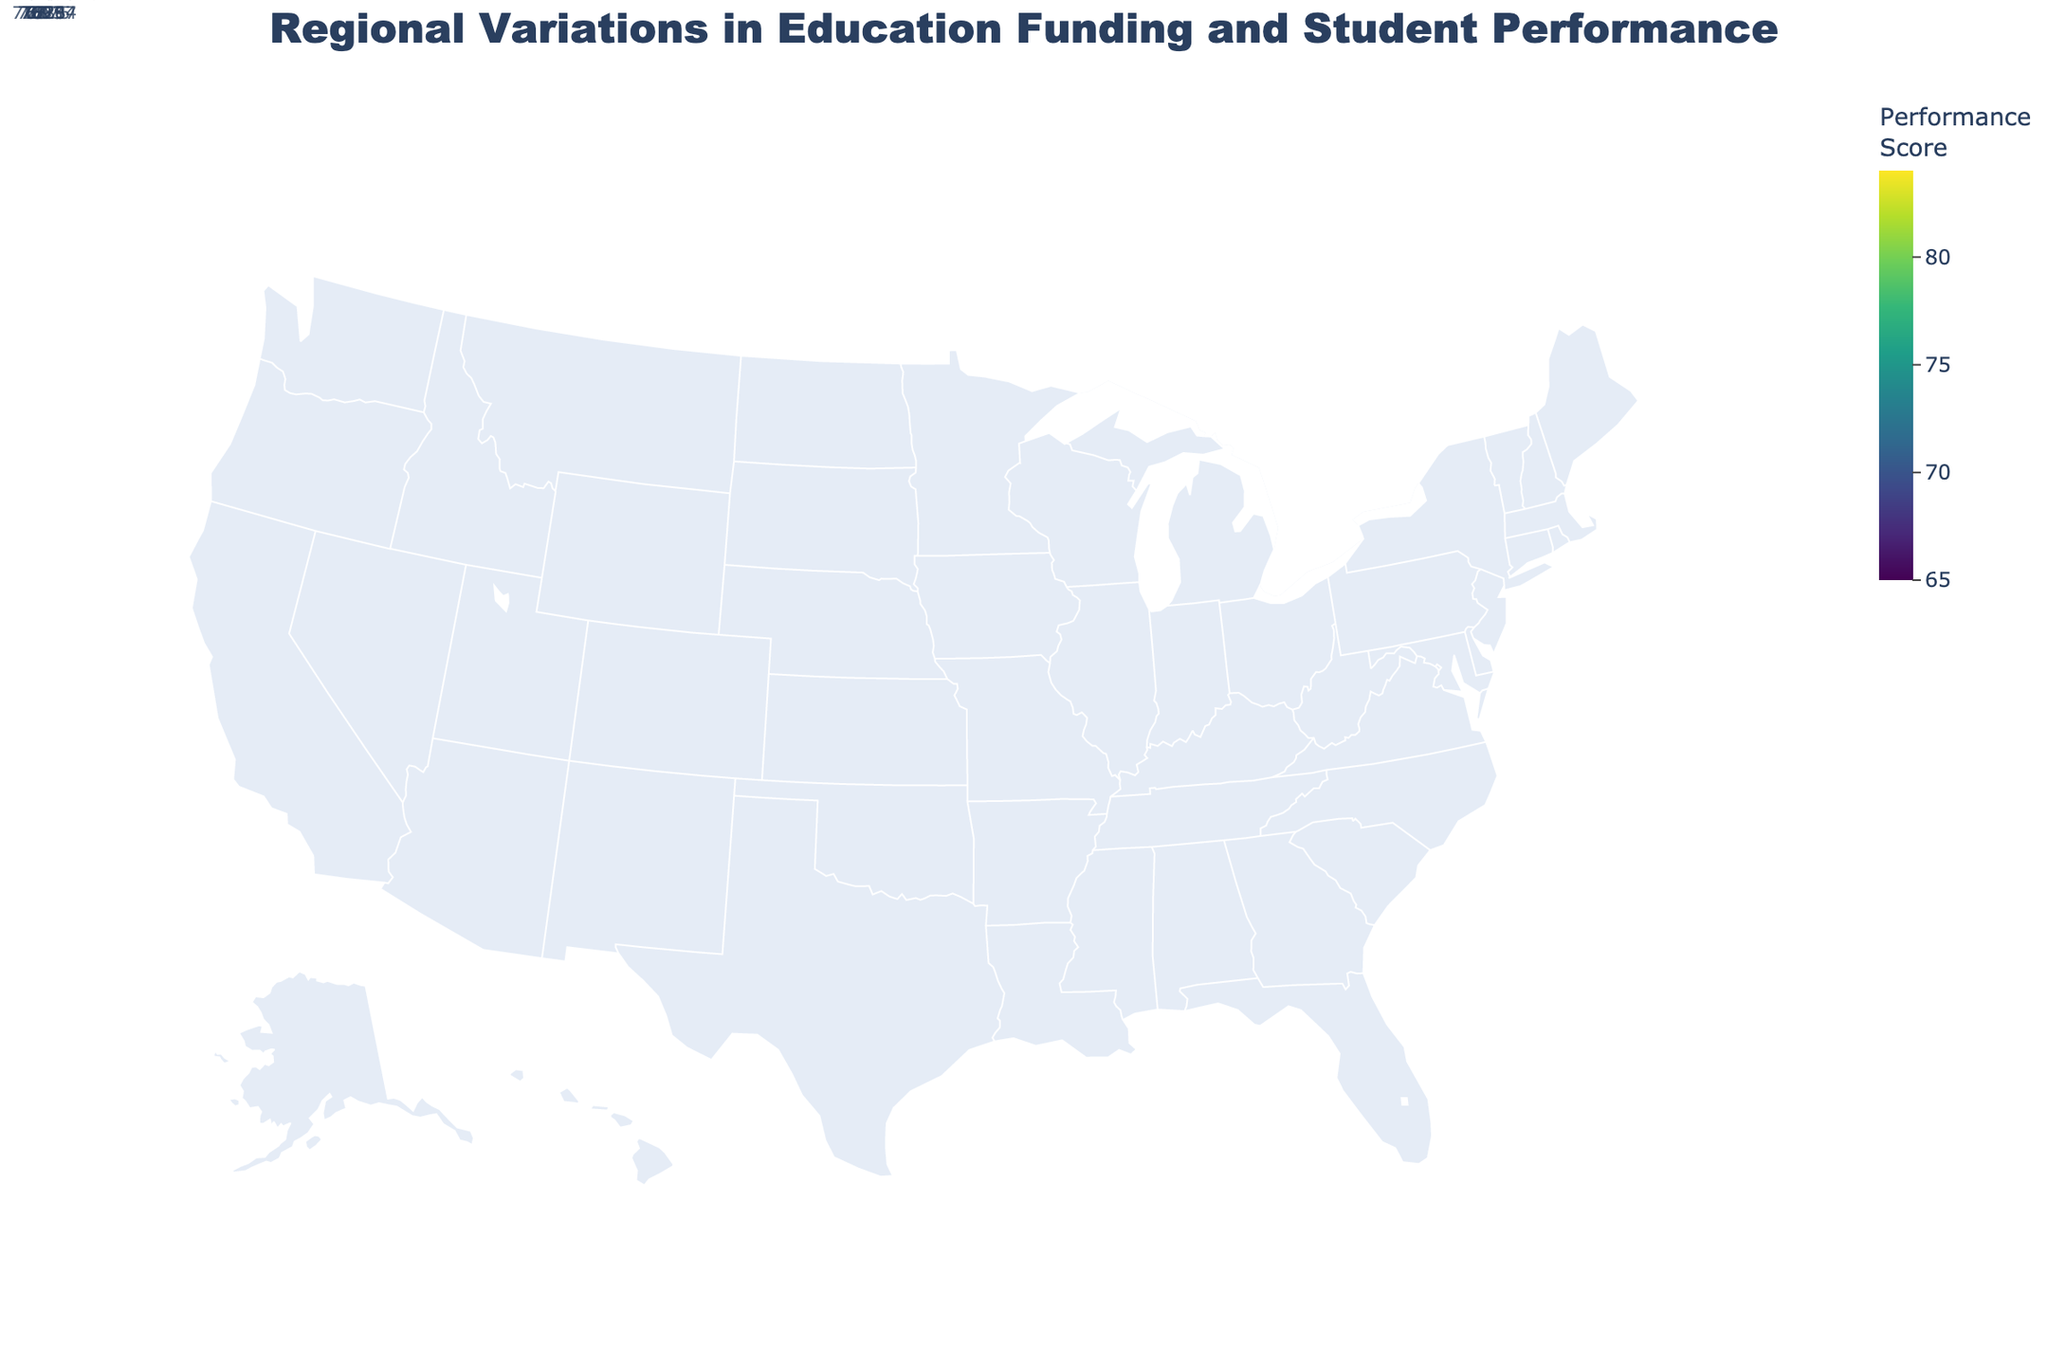What is the title of the figure? The title is given at the top of the figure. It summarizes the information presented.
Answer: Regional Variations in Education Funding and Student Performance Which state has the highest student performance score? Look at the states colored with the darkest shade on the color scale, which indicates higher performance scores, and identify the state with the score of 84.
Answer: Massachusetts How much is the education funding per student in Texas? Check the hover data for Texas, which shows detailed information including education funding per student.
Answer: $9800 What's the difference in student performance scores between California and Michigan? Note the performance scores for both California (78) and Michigan (69) and subtract the lower score from the higher score.
Answer: 9 Which region recommends the largest budget reallocation? Identify the state with the highest value for the 'Recommended Budget Reallocation'. The state with the largest reallocation percentage is 35%.
Answer: Arizona What is the average student performance score across all states? Add up all the student performance scores and divide by the number of states (15 states). Calculation: (78 + 72 + 82 + 70 + 76 + 75 + 71 + 69 + 68 + 67 + 77 + 79 + 84 + 83 + 65) / 15.
Answer: 74.1 How does Florida's student performance score compare to the national average? Determine Florida’s performance score, then calculate the overall average score (as done in the prior question), and compare the two values.
Answer: Florida's score is 70, which is below the national average of 74.1 Which state has a higher education funding per student, New York or New Jersey? Compare the education funding values given for New York ($14200) and New Jersey ($13500).
Answer: New York What is the range of student performance scores? Identify the highest and lowest performance scores in the figure and calculate the difference. The highest score is 84 (Massachusetts) and the lowest is 65 (Arizona).
Answer: 19 How does the recommended budget reallocation for Georgia compare to that for Pennsylvania? Look at the recommended budget reallocations for Georgia (30%) and Pennsylvania (22%) and compare them.
Answer: Georgia's is 8 percentage points higher than Pennsylvania's 